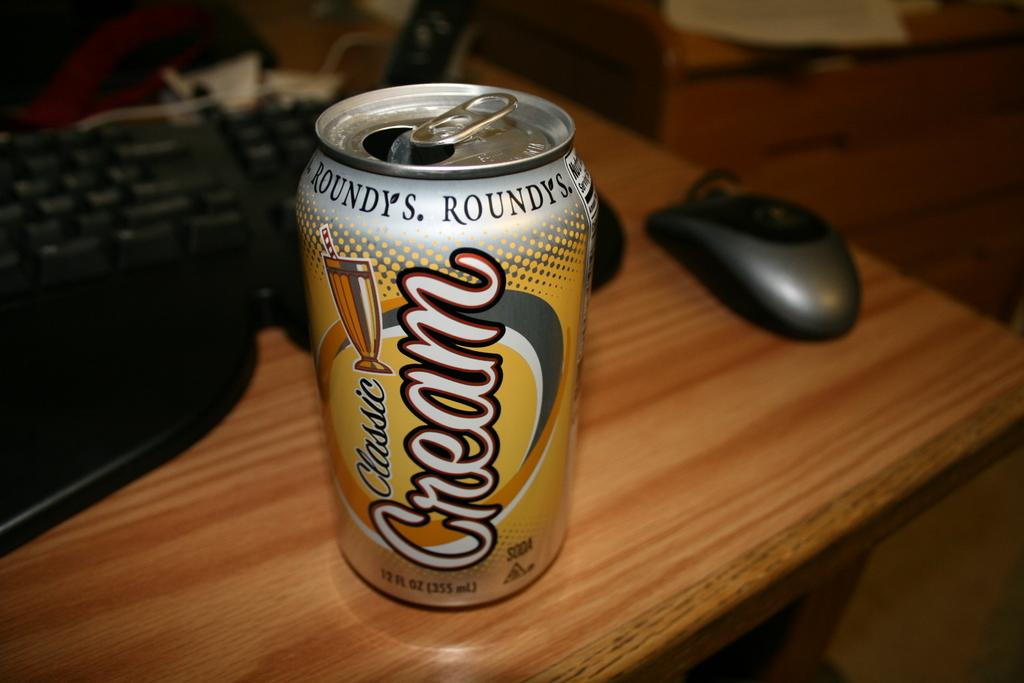Provide a one-sentence caption for the provided image. A can of Classic Cream Roundy's soda on a wood table. 